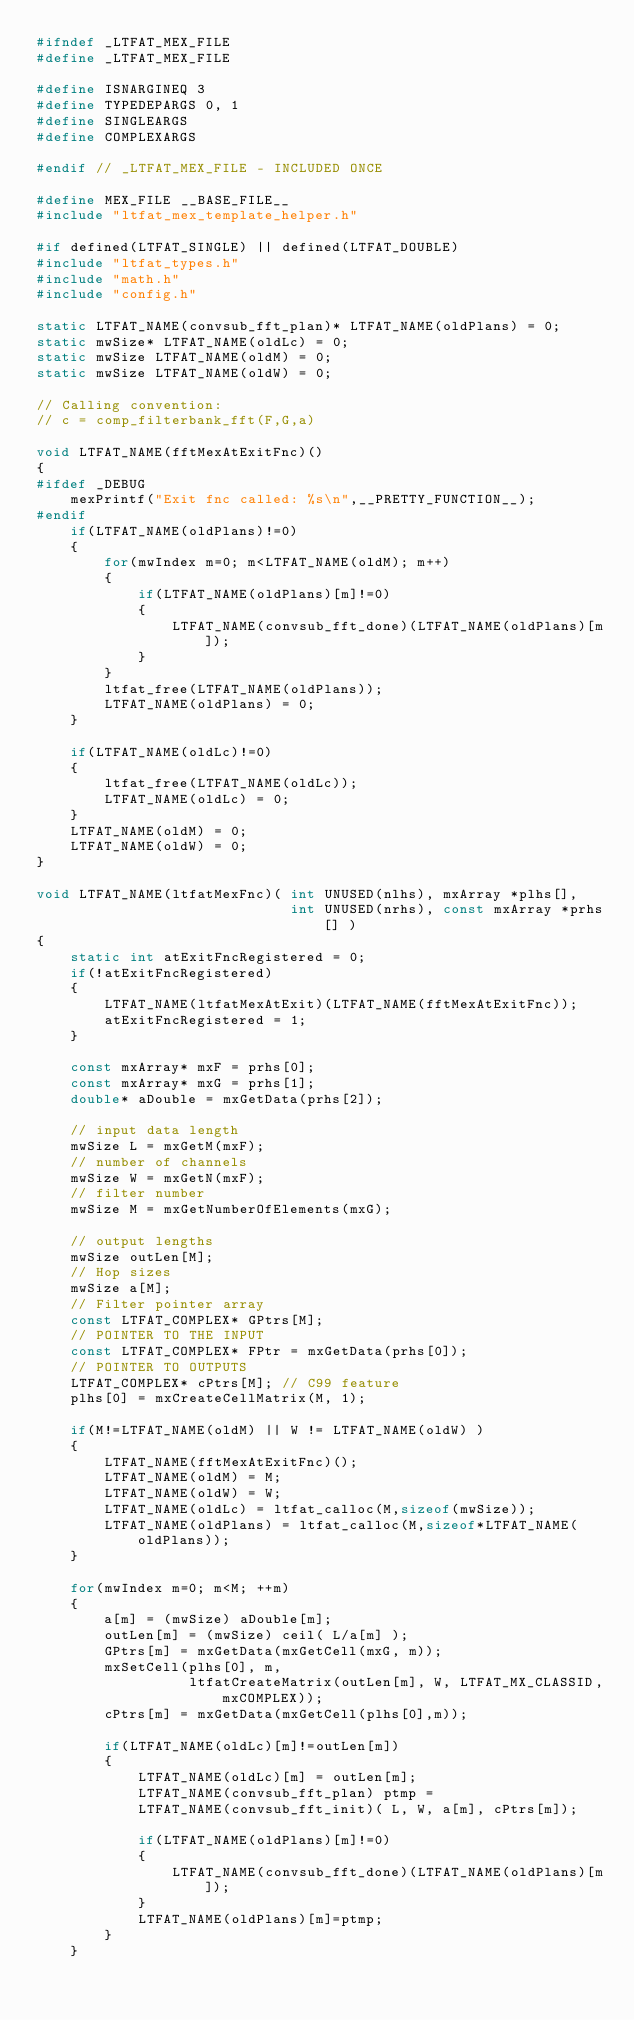Convert code to text. <code><loc_0><loc_0><loc_500><loc_500><_C_>#ifndef _LTFAT_MEX_FILE
#define _LTFAT_MEX_FILE

#define ISNARGINEQ 3
#define TYPEDEPARGS 0, 1
#define SINGLEARGS
#define COMPLEXARGS

#endif // _LTFAT_MEX_FILE - INCLUDED ONCE

#define MEX_FILE __BASE_FILE__
#include "ltfat_mex_template_helper.h"

#if defined(LTFAT_SINGLE) || defined(LTFAT_DOUBLE)
#include "ltfat_types.h"
#include "math.h"
#include "config.h"

static LTFAT_NAME(convsub_fft_plan)* LTFAT_NAME(oldPlans) = 0;
static mwSize* LTFAT_NAME(oldLc) = 0;
static mwSize LTFAT_NAME(oldM) = 0;
static mwSize LTFAT_NAME(oldW) = 0;

// Calling convention:
// c = comp_filterbank_fft(F,G,a)

void LTFAT_NAME(fftMexAtExitFnc)()
{
#ifdef _DEBUG
    mexPrintf("Exit fnc called: %s\n",__PRETTY_FUNCTION__);
#endif
    if(LTFAT_NAME(oldPlans)!=0)
    {
        for(mwIndex m=0; m<LTFAT_NAME(oldM); m++)
        {
            if(LTFAT_NAME(oldPlans)[m]!=0)
            {
                LTFAT_NAME(convsub_fft_done)(LTFAT_NAME(oldPlans)[m]);
            }
        }
        ltfat_free(LTFAT_NAME(oldPlans));
        LTFAT_NAME(oldPlans) = 0;
    }

    if(LTFAT_NAME(oldLc)!=0)
    {
        ltfat_free(LTFAT_NAME(oldLc));
        LTFAT_NAME(oldLc) = 0;
    }
    LTFAT_NAME(oldM) = 0;
    LTFAT_NAME(oldW) = 0;
}

void LTFAT_NAME(ltfatMexFnc)( int UNUSED(nlhs), mxArray *plhs[],
                              int UNUSED(nrhs), const mxArray *prhs[] )
{
    static int atExitFncRegistered = 0;
    if(!atExitFncRegistered)
    {
        LTFAT_NAME(ltfatMexAtExit)(LTFAT_NAME(fftMexAtExitFnc));
        atExitFncRegistered = 1;
    }

    const mxArray* mxF = prhs[0];
    const mxArray* mxG = prhs[1];
    double* aDouble = mxGetData(prhs[2]);

    // input data length
    mwSize L = mxGetM(mxF);
    // number of channels
    mwSize W = mxGetN(mxF);
    // filter number
    mwSize M = mxGetNumberOfElements(mxG);

    // output lengths
    mwSize outLen[M];
    // Hop sizes
    mwSize a[M];
    // Filter pointer array
    const LTFAT_COMPLEX* GPtrs[M];
    // POINTER TO THE INPUT
    const LTFAT_COMPLEX* FPtr = mxGetData(prhs[0]);
    // POINTER TO OUTPUTS
    LTFAT_COMPLEX* cPtrs[M]; // C99 feature
    plhs[0] = mxCreateCellMatrix(M, 1);

    if(M!=LTFAT_NAME(oldM) || W != LTFAT_NAME(oldW) )
    {
        LTFAT_NAME(fftMexAtExitFnc)();
        LTFAT_NAME(oldM) = M;
        LTFAT_NAME(oldW) = W;
        LTFAT_NAME(oldLc) = ltfat_calloc(M,sizeof(mwSize));
        LTFAT_NAME(oldPlans) = ltfat_calloc(M,sizeof*LTFAT_NAME(oldPlans));
    }

    for(mwIndex m=0; m<M; ++m)
    {
        a[m] = (mwSize) aDouble[m];
        outLen[m] = (mwSize) ceil( L/a[m] );
        GPtrs[m] = mxGetData(mxGetCell(mxG, m));
        mxSetCell(plhs[0], m,
                  ltfatCreateMatrix(outLen[m], W, LTFAT_MX_CLASSID,mxCOMPLEX));
        cPtrs[m] = mxGetData(mxGetCell(plhs[0],m));

        if(LTFAT_NAME(oldLc)[m]!=outLen[m])
        {
            LTFAT_NAME(oldLc)[m] = outLen[m];
            LTFAT_NAME(convsub_fft_plan) ptmp =
            LTFAT_NAME(convsub_fft_init)( L, W, a[m], cPtrs[m]);

            if(LTFAT_NAME(oldPlans)[m]!=0)
            {
                LTFAT_NAME(convsub_fft_done)(LTFAT_NAME(oldPlans)[m]);
            }
            LTFAT_NAME(oldPlans)[m]=ptmp;
        }
    }
</code> 